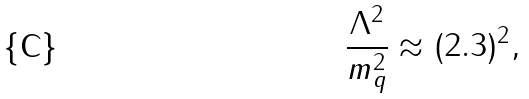Convert formula to latex. <formula><loc_0><loc_0><loc_500><loc_500>\frac { \Lambda ^ { 2 } } { m _ { q } ^ { 2 } } \approx ( 2 . 3 ) ^ { 2 } ,</formula> 